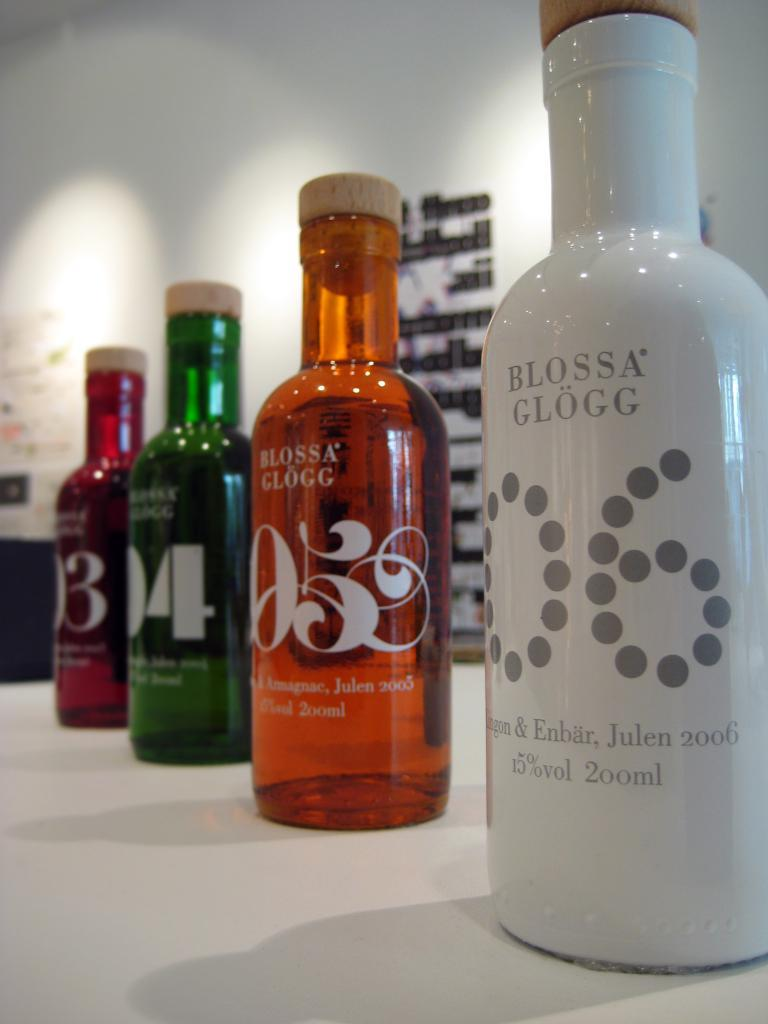<image>
Create a compact narrative representing the image presented. four colorful bottles of Blossa Glogg on a table 